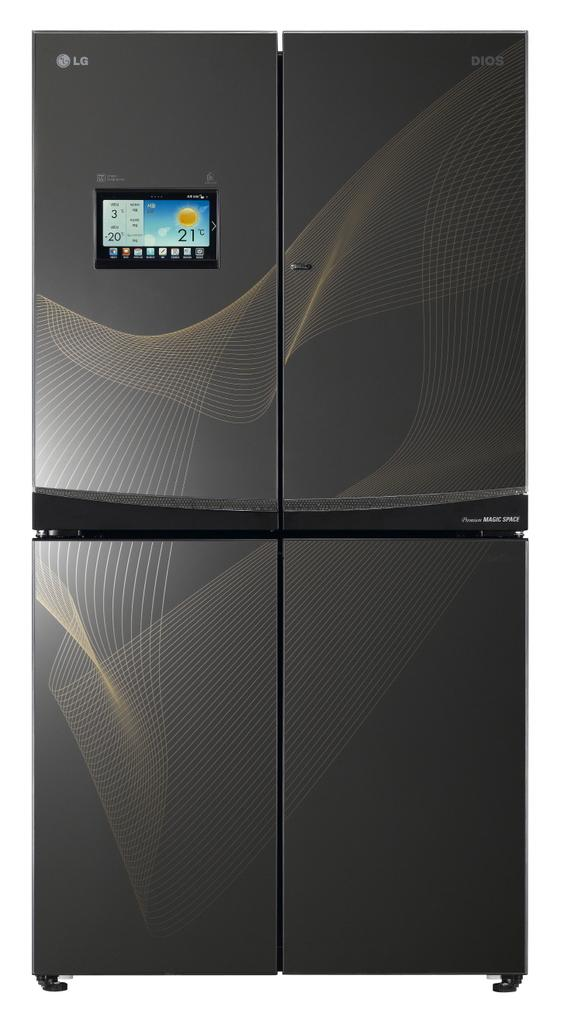<image>
Render a clear and concise summary of the photo. An LG refrigerator has a screen displaying the weather. 